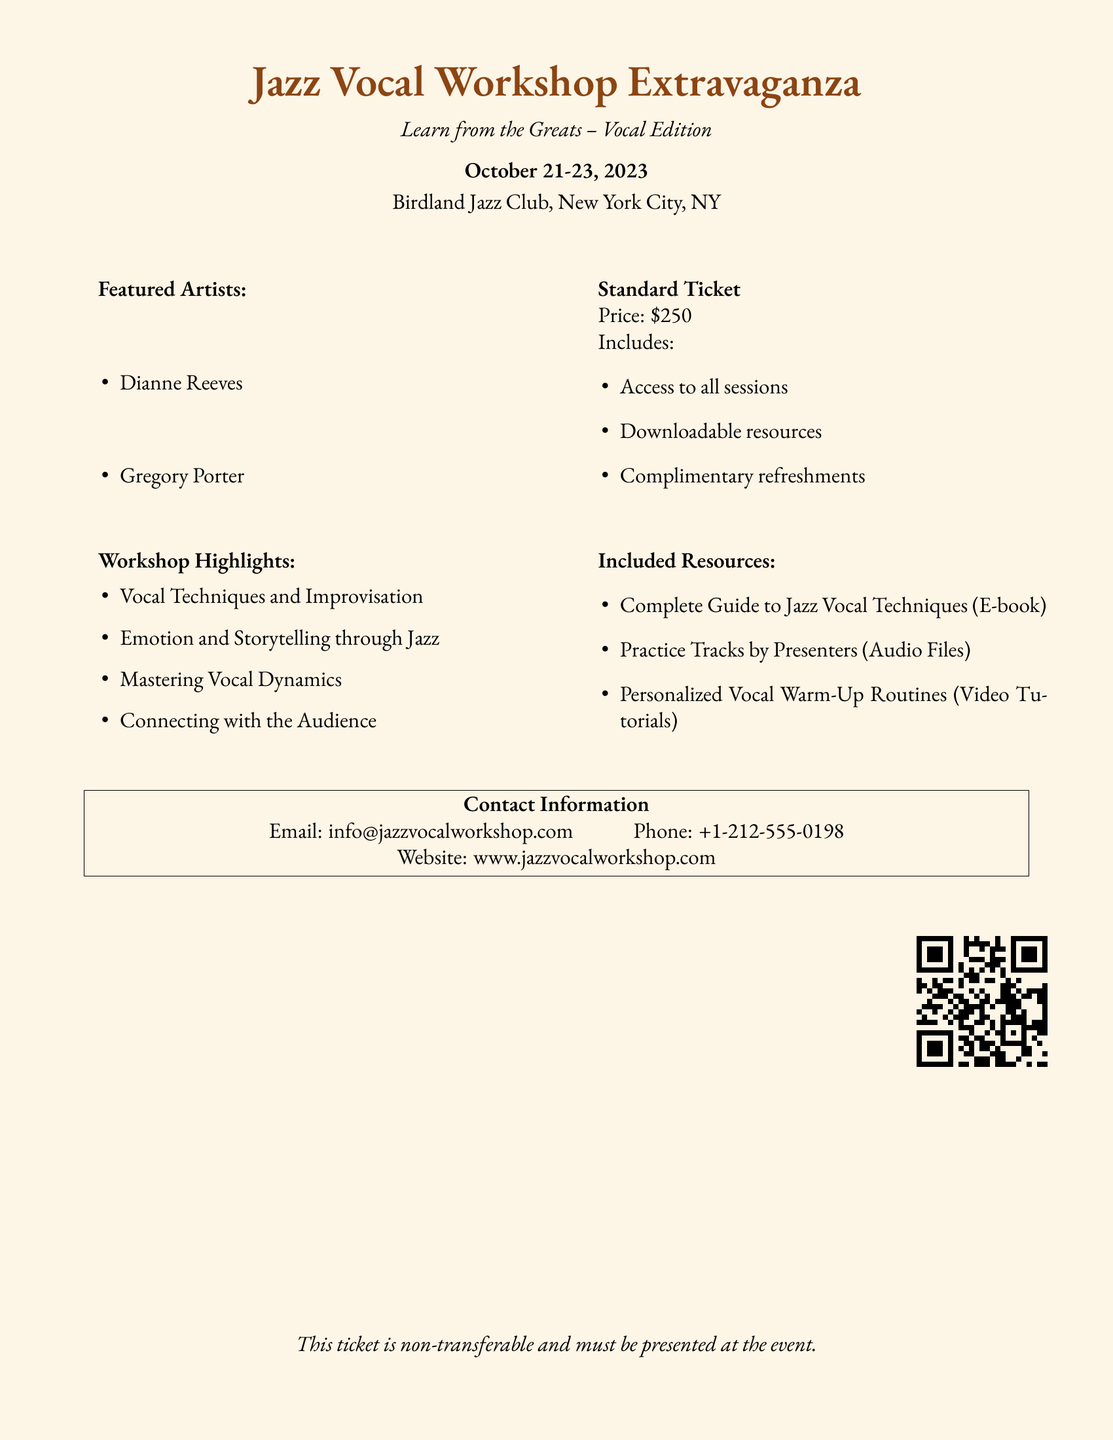What are the dates of the workshop? The dates listed in the document for the workshop are from October 21 to October 23, 2023.
Answer: October 21-23, 2023 Who are the featured artists? The workshop features renowned vocal artists, specifically named in the document as Dianne Reeves and Gregory Porter.
Answer: Dianne Reeves, Gregory Porter What is the price of a standard ticket? The document states that the price for the standard ticket is $250.
Answer: $250 What type of resources are included? The document lists several resources included with the ticket, specifically mentioning an E-book, audio files, and video tutorials.
Answer: Complete Guide to Jazz Vocal Techniques, Practice Tracks, Personalized Vocal Warm-Up Routines What is one of the workshop highlights? The document provides a list of highlights from the workshop which includes various topics like vocal techniques, emotion, and storytelling.
Answer: Vocal Techniques and Improvisation What kind of refreshments are provided? The document indicates that complimentary refreshments are included with the standard ticket.
Answer: Complimentary refreshments How can I contact the workshop organizers? Contact information is provided in the document, which includes an email address and a phone number for inquiries.
Answer: info@jazzvocalworkshop.com, +1-212-555-0198 What type of event is this document for? The document is specifically for a jazz vocal workshop, as clearly stated in the title and description.
Answer: Jazz Vocal Workshop 